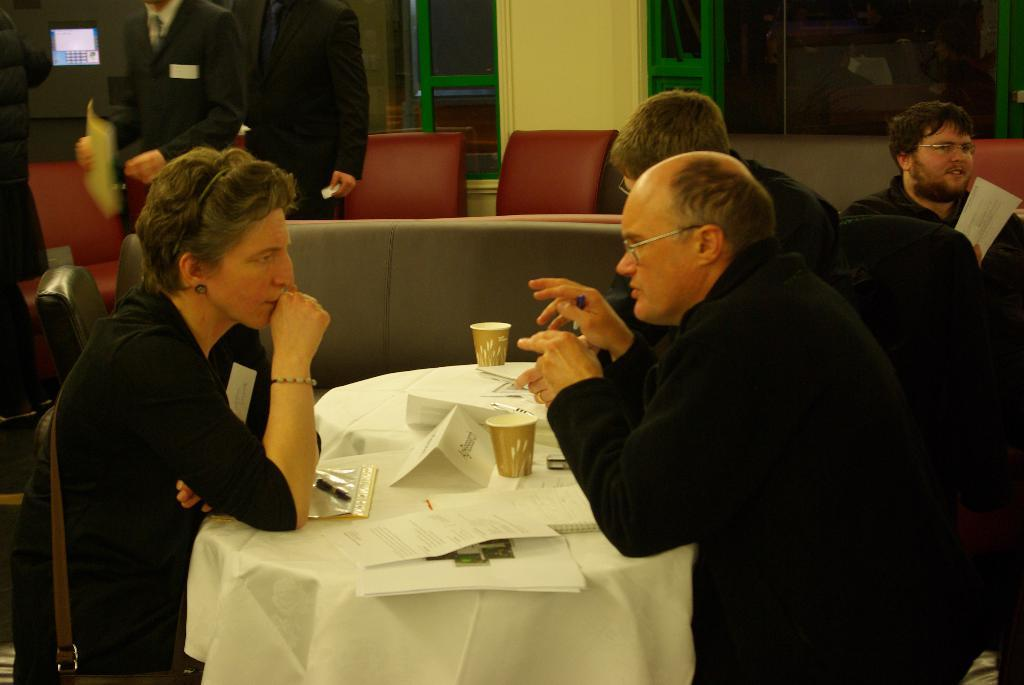How many people are sitting in the image? There are three people sitting on chairs in the image. What objects can be seen on the table? There are two cups and a plate on the table in the image. Where is the table located in the image? The table is in the background of the image. What is the person on the wall doing? There is another person sitting on a wall in the image. What is visible through the window in the image? Unfortunately, the facts provided do not mention what can be seen through the window. What type of collar can be seen on the lizards in the image? There are no lizards present in the image, so there is no collar to be seen. 